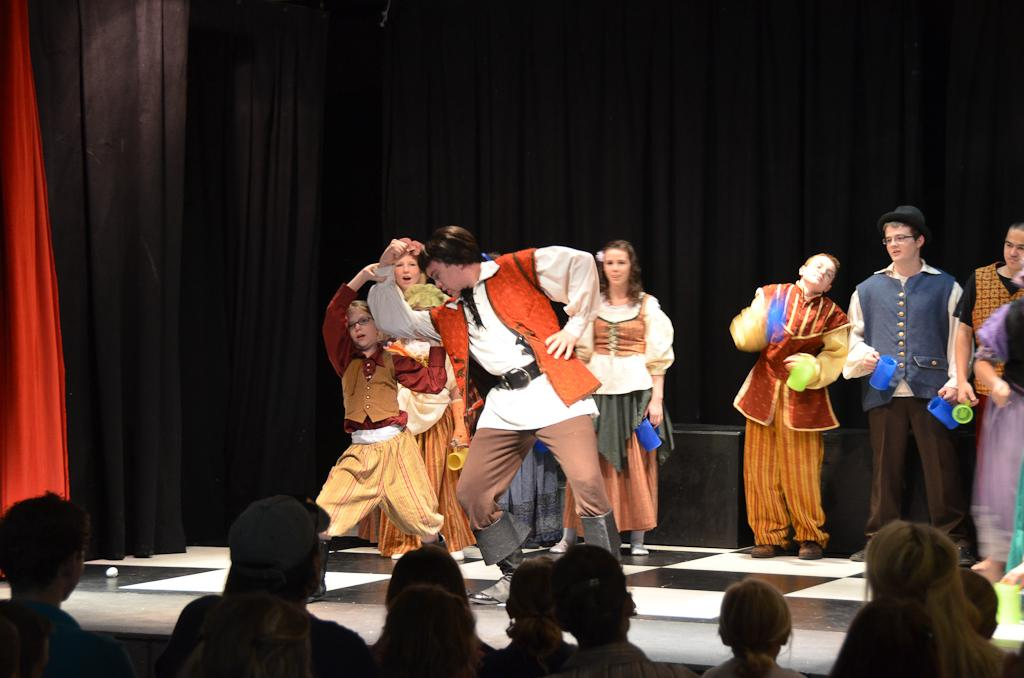What is happening on the stage in the image? There is a group of people on the stage in the image. How many people are visible in the image? There are at least a few persons in the image. What can be seen in the background of the stage? There are curtains in the background of the image. What color is the grape that one of the persons is holding in the image? There is no grape present in the image, so it is not possible to determine its color. 